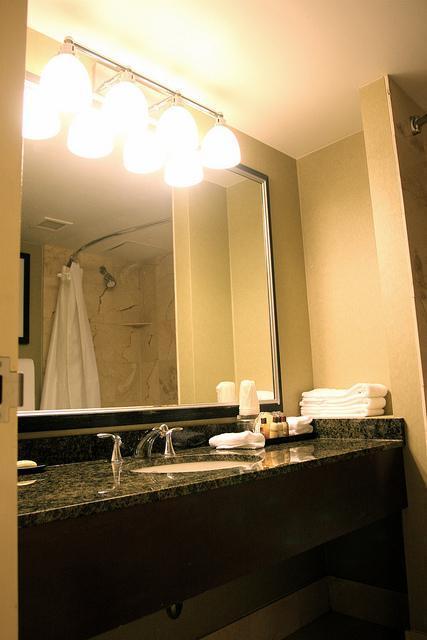How many lights are there?
Give a very brief answer. 4. 